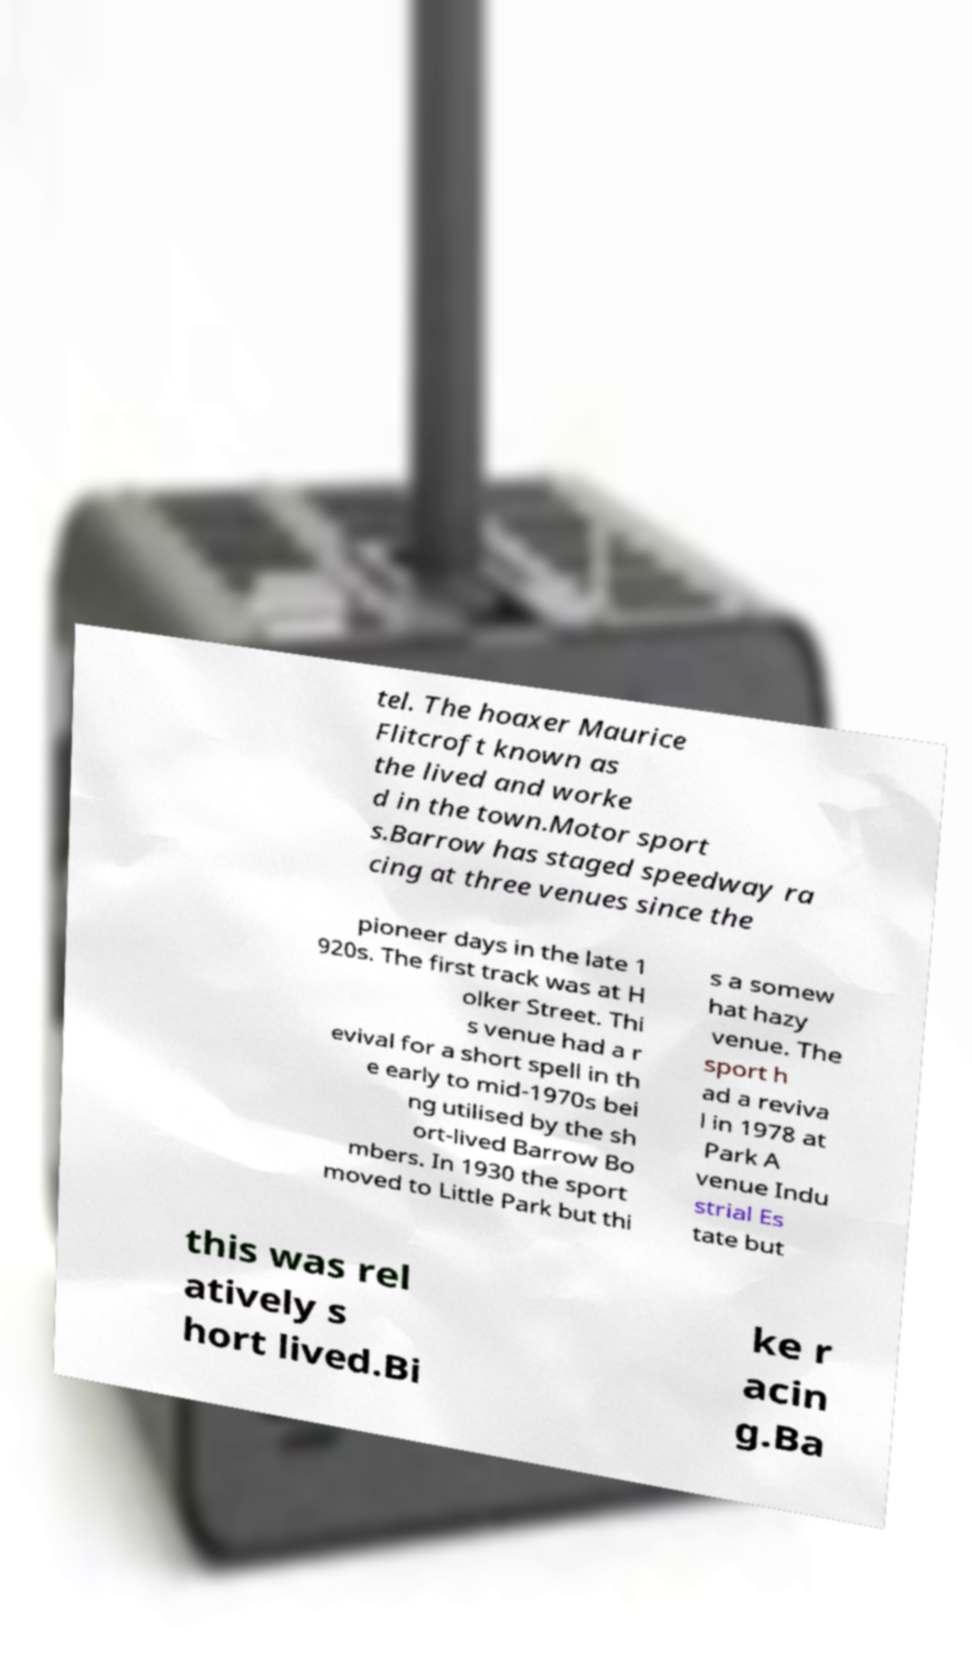What messages or text are displayed in this image? I need them in a readable, typed format. tel. The hoaxer Maurice Flitcroft known as the lived and worke d in the town.Motor sport s.Barrow has staged speedway ra cing at three venues since the pioneer days in the late 1 920s. The first track was at H olker Street. Thi s venue had a r evival for a short spell in th e early to mid-1970s bei ng utilised by the sh ort-lived Barrow Bo mbers. In 1930 the sport moved to Little Park but thi s a somew hat hazy venue. The sport h ad a reviva l in 1978 at Park A venue Indu strial Es tate but this was rel atively s hort lived.Bi ke r acin g.Ba 